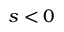Convert formula to latex. <formula><loc_0><loc_0><loc_500><loc_500>s < 0</formula> 